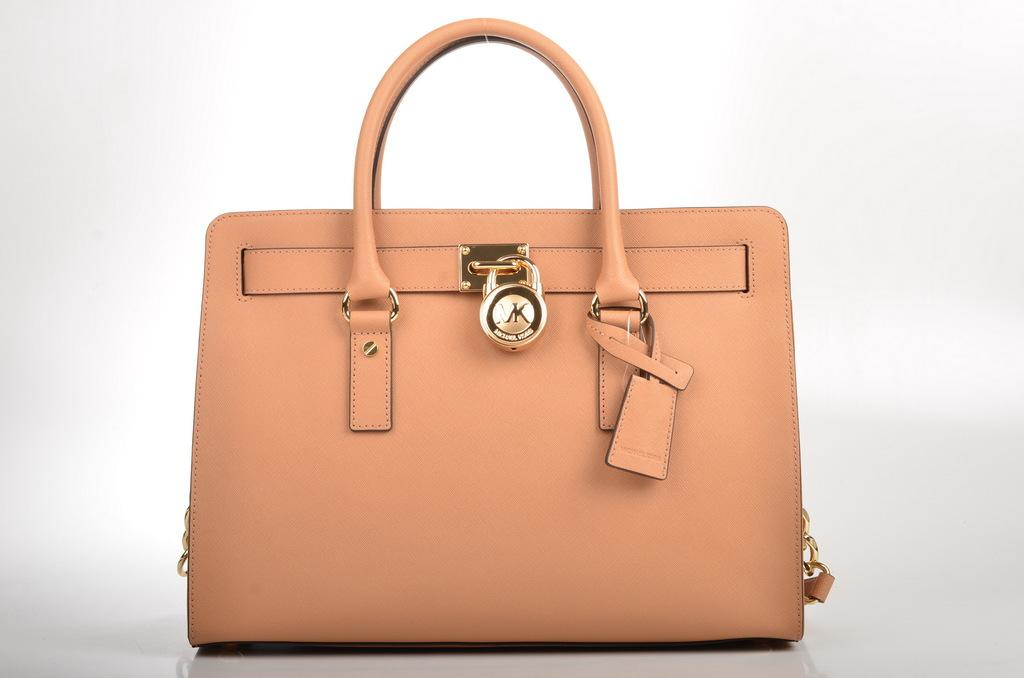What type of bag is in the picture? There is a beautiful brown bag in the picture. What is the name of the bag? The bag is named CK. What type of seed is growing inside the bag in the image? There is no seed or plant growing inside the bag in the image; it is a brown bag named CK. 